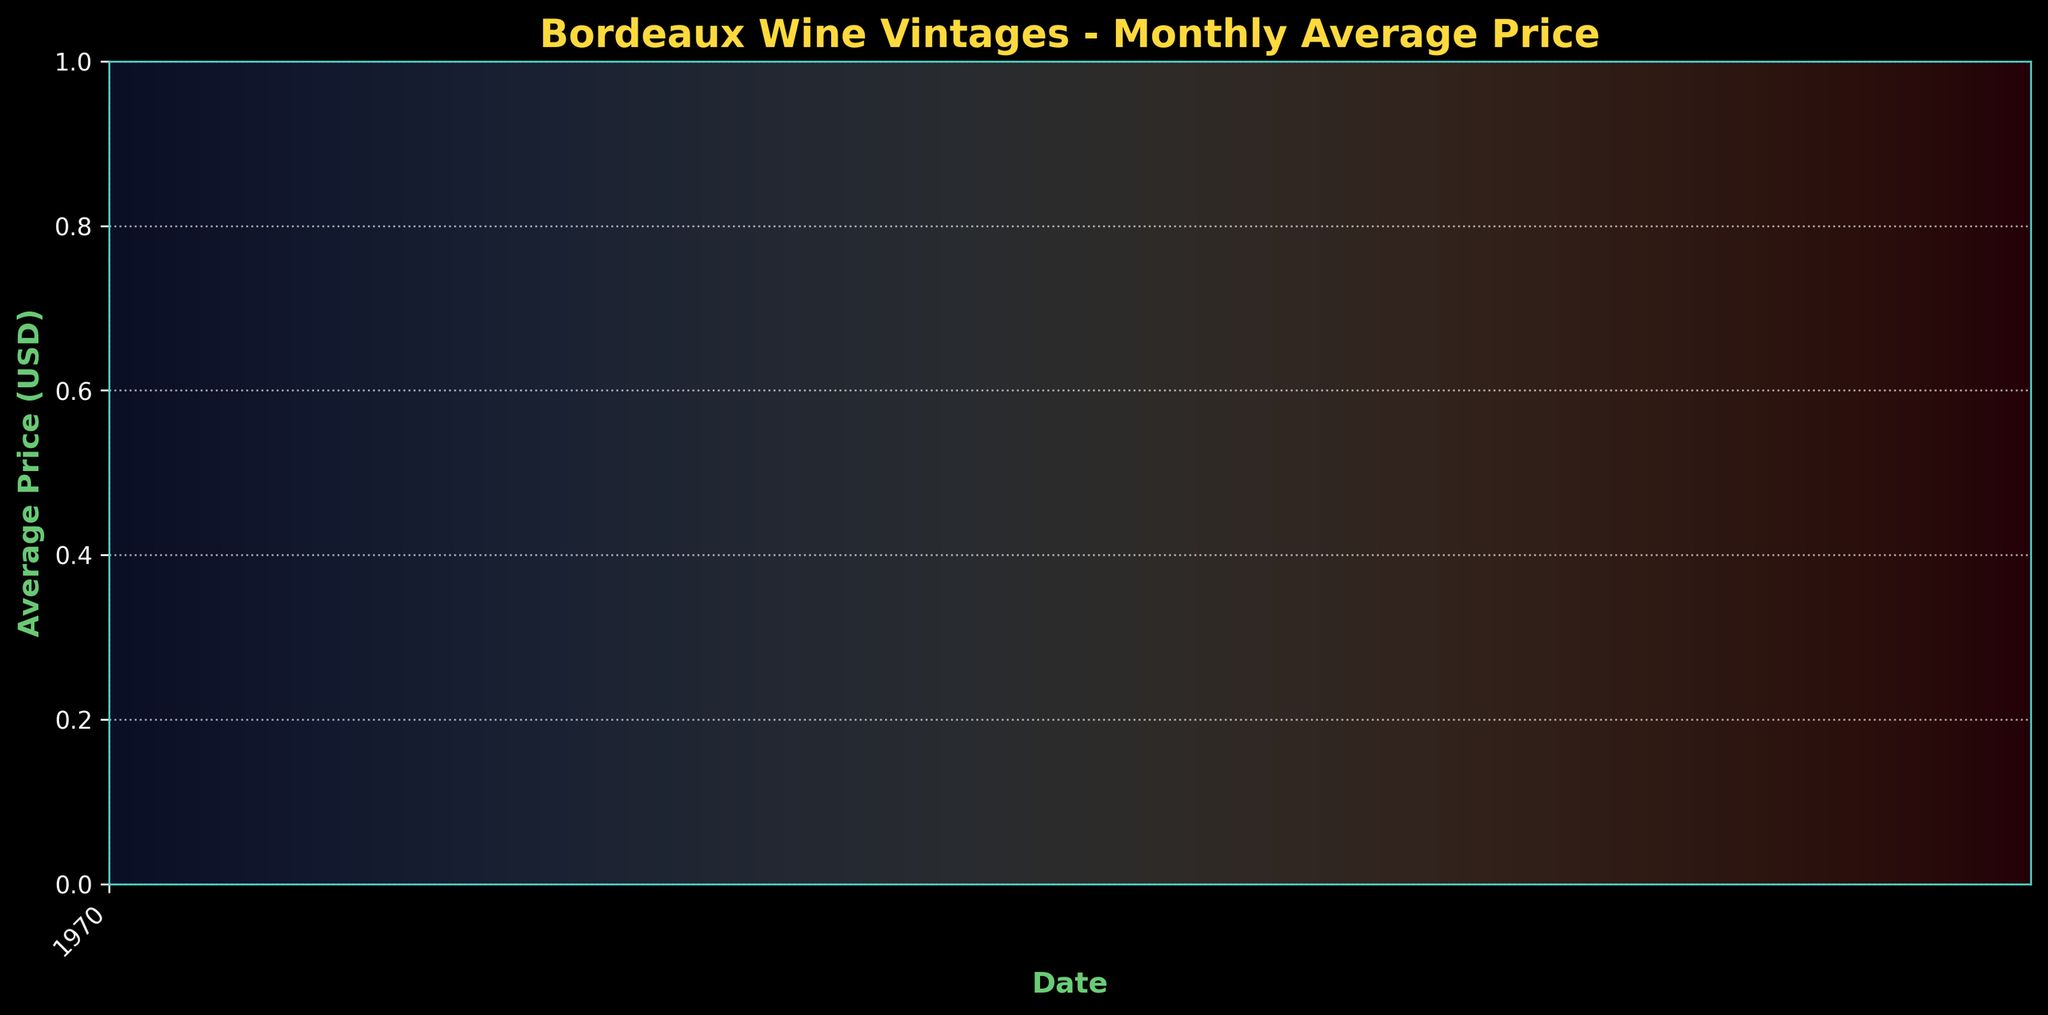What is the title of the figure? The title is displayed at the top of the figure. It reads "Bordeaux Wine Vintages - Monthly Average Price".
Answer: Bordeaux Wine Vintages - Monthly Average Price What are the units on the y-axis? The units on the y-axis are indicated by the y-axis label, "Average Price (USD)".
Answer: Average Price (USD) Which month-year recorded the highest average price? The highest average price is annotated in the plot with a marker and text "Max: $61.50" near the point in 2023-03.
Answer: 2023-03 How often are the major ticks on the x-axis? The major ticks are positioned every two years, as indicated by the x-axis labels (e.g., 2008, 2010, 2012).
Answer: Every two years How many data points are plotted on the figure? There are several visible data points marked by circular markers. Counting them gives us 20 data points.
Answer: 20 What was the average price in February 2023? Find the data point at February 2023 on the x-axis and check the corresponding y-axis value. The average price in February 2023 is $61.30.
Answer: $61.30 What is the difference between the average wine prices in January 2008 and January 2023? Locate and subtract the value of January 2008 ($45.32) from the value of January 2023 ($61.10). The difference is $61.10 - $45.32 = $15.78.
Answer: $15.78 Did the average price increase or decrease from January 2023 to March 2023? Look at the trend from January 2023 to March 2023. The prices go from $61.10 in January to $61.50 in March, showing an increase.
Answer: Increase Which period shows a larger increase in the average price: from 2015-11 to 2016-02 or from 2022-11 to 2023-03? Compare the price difference for both periods. From 2015-11 ($49.88) to 2016-02 ($51.35) the change is $51.35 - $49.88 = $1.47. From 2022-11 ($60.45) to 2023-03 ($61.50) the change is $61.50 - $60.45 = $1.05. The first period shows a larger increase.
Answer: 2015-11 to 2016-02 What is the general trend of Bordeaux wine prices from 2008 to 2023? By visually inspecting the plot from left to right (2008 to 2023), we observe a general increasing trend in the average price.
Answer: Increasing trend 